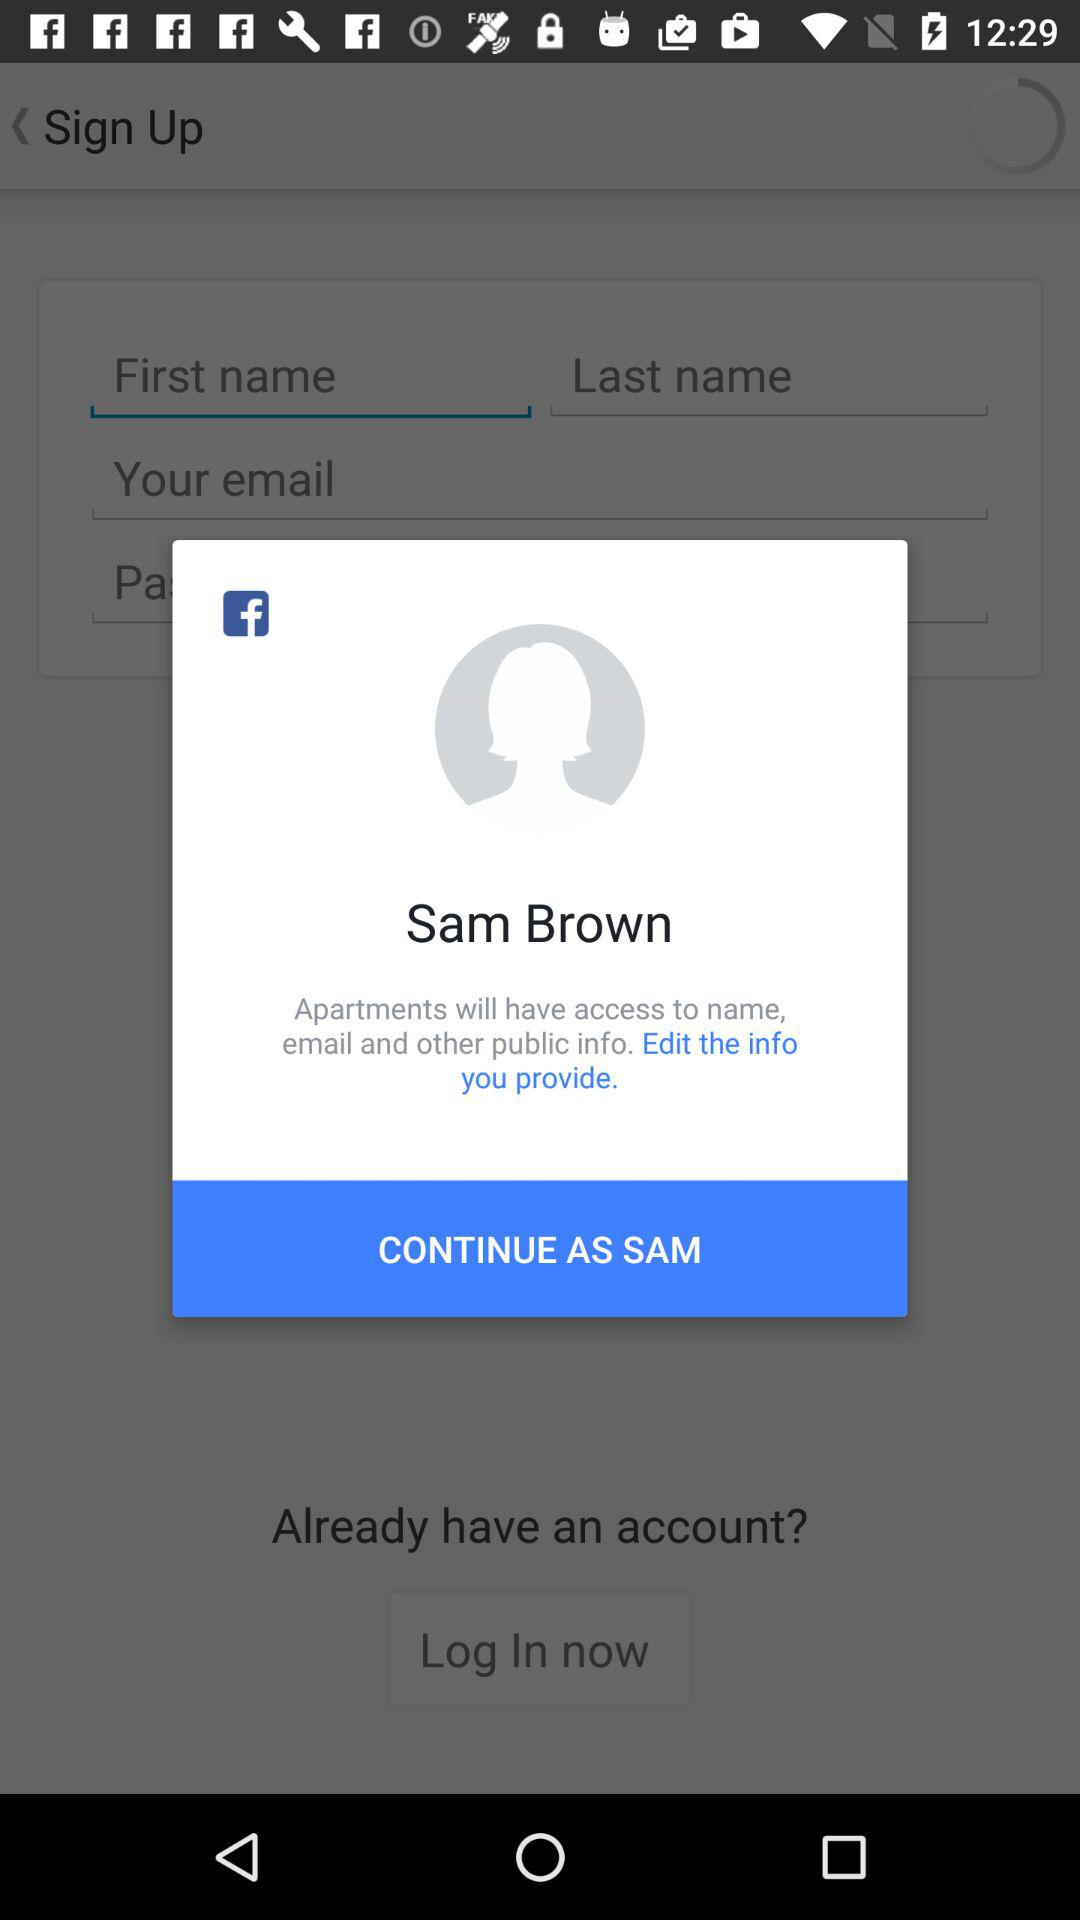What is Sam Brown's email address?
When the provided information is insufficient, respond with <no answer>. <no answer> 